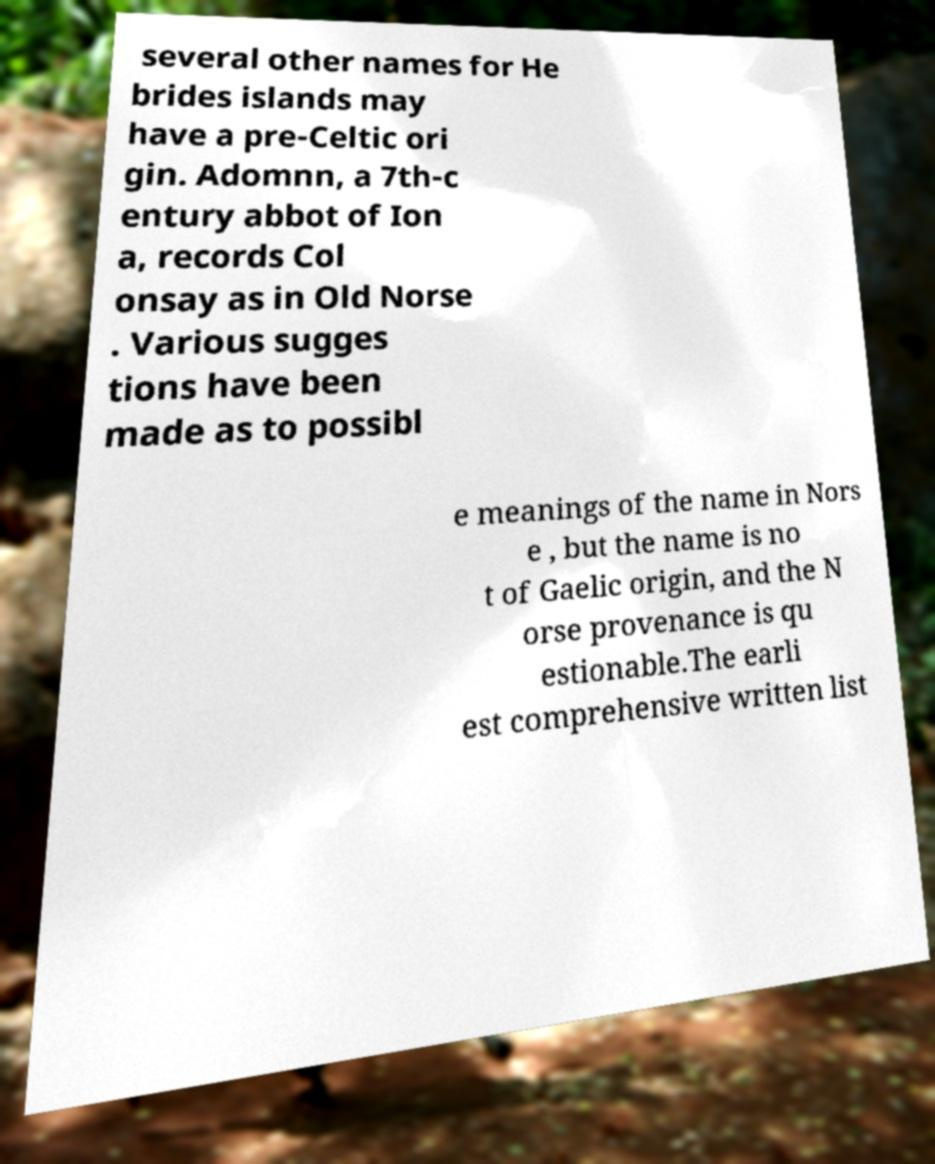For documentation purposes, I need the text within this image transcribed. Could you provide that? several other names for He brides islands may have a pre-Celtic ori gin. Adomnn, a 7th-c entury abbot of Ion a, records Col onsay as in Old Norse . Various sugges tions have been made as to possibl e meanings of the name in Nors e , but the name is no t of Gaelic origin, and the N orse provenance is qu estionable.The earli est comprehensive written list 